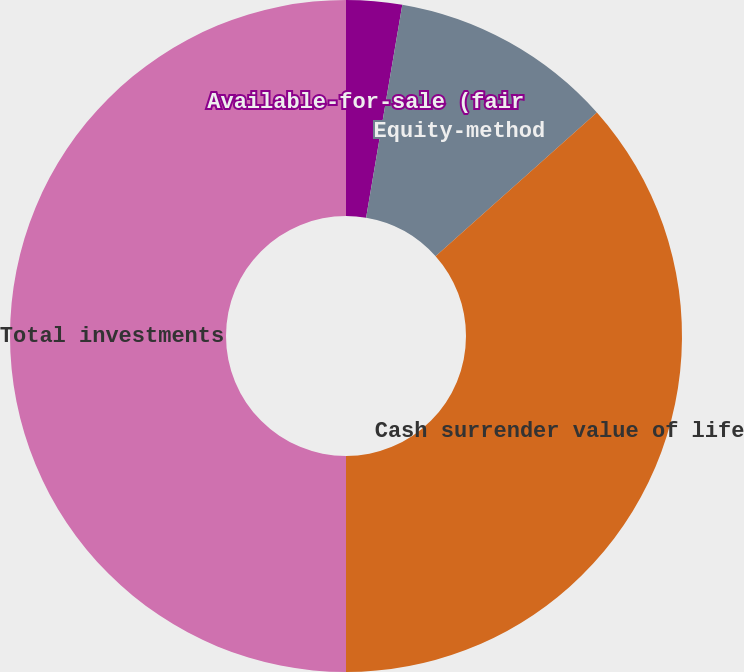Convert chart to OTSL. <chart><loc_0><loc_0><loc_500><loc_500><pie_chart><fcel>Available-for-sale (fair<fcel>Equity-method<fcel>Cash surrender value of life<fcel>Total investments<nl><fcel>2.68%<fcel>10.74%<fcel>36.58%<fcel>50.0%<nl></chart> 